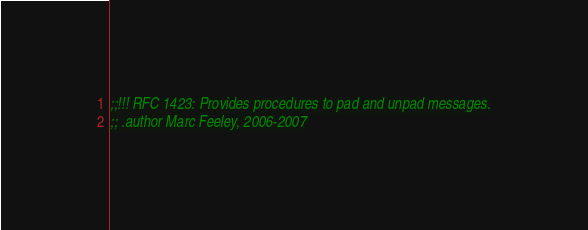Convert code to text. <code><loc_0><loc_0><loc_500><loc_500><_Scheme_>;;!!! RFC 1423: Provides procedures to pad and unpad messages.
;; .author Marc Feeley, 2006-2007</code> 